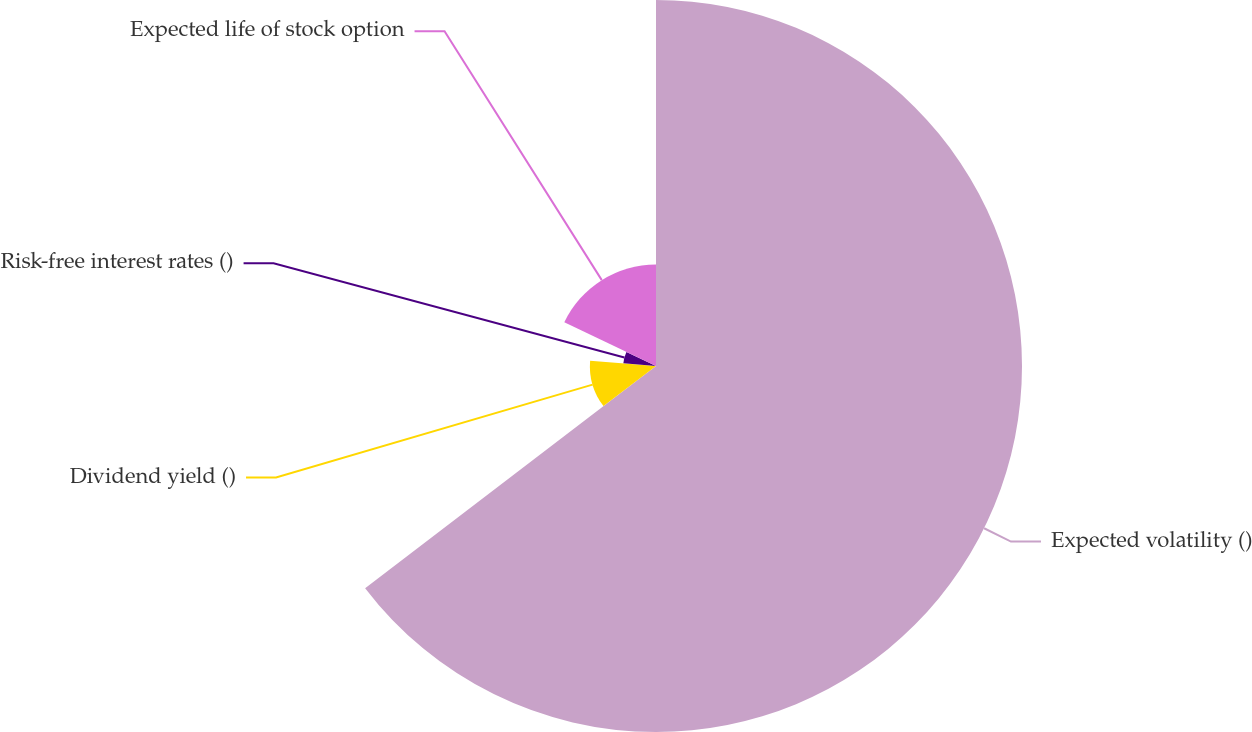<chart> <loc_0><loc_0><loc_500><loc_500><pie_chart><fcel>Expected volatility ()<fcel>Dividend yield ()<fcel>Risk-free interest rates ()<fcel>Expected life of stock option<nl><fcel>64.62%<fcel>11.67%<fcel>5.78%<fcel>17.93%<nl></chart> 